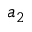Convert formula to latex. <formula><loc_0><loc_0><loc_500><loc_500>a _ { 2 }</formula> 